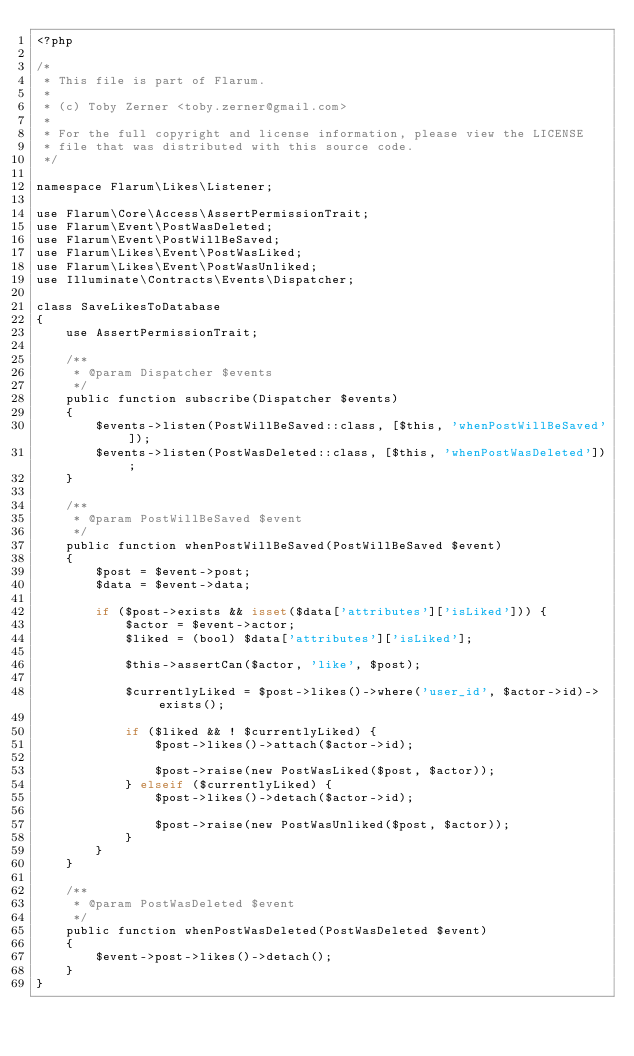Convert code to text. <code><loc_0><loc_0><loc_500><loc_500><_PHP_><?php

/*
 * This file is part of Flarum.
 *
 * (c) Toby Zerner <toby.zerner@gmail.com>
 *
 * For the full copyright and license information, please view the LICENSE
 * file that was distributed with this source code.
 */

namespace Flarum\Likes\Listener;

use Flarum\Core\Access\AssertPermissionTrait;
use Flarum\Event\PostWasDeleted;
use Flarum\Event\PostWillBeSaved;
use Flarum\Likes\Event\PostWasLiked;
use Flarum\Likes\Event\PostWasUnliked;
use Illuminate\Contracts\Events\Dispatcher;

class SaveLikesToDatabase
{
    use AssertPermissionTrait;

    /**
     * @param Dispatcher $events
     */
    public function subscribe(Dispatcher $events)
    {
        $events->listen(PostWillBeSaved::class, [$this, 'whenPostWillBeSaved']);
        $events->listen(PostWasDeleted::class, [$this, 'whenPostWasDeleted']);
    }

    /**
     * @param PostWillBeSaved $event
     */
    public function whenPostWillBeSaved(PostWillBeSaved $event)
    {
        $post = $event->post;
        $data = $event->data;

        if ($post->exists && isset($data['attributes']['isLiked'])) {
            $actor = $event->actor;
            $liked = (bool) $data['attributes']['isLiked'];

            $this->assertCan($actor, 'like', $post);

            $currentlyLiked = $post->likes()->where('user_id', $actor->id)->exists();

            if ($liked && ! $currentlyLiked) {
                $post->likes()->attach($actor->id);

                $post->raise(new PostWasLiked($post, $actor));
            } elseif ($currentlyLiked) {
                $post->likes()->detach($actor->id);

                $post->raise(new PostWasUnliked($post, $actor));
            }
        }
    }

    /**
     * @param PostWasDeleted $event
     */
    public function whenPostWasDeleted(PostWasDeleted $event)
    {
        $event->post->likes()->detach();
    }
}
</code> 